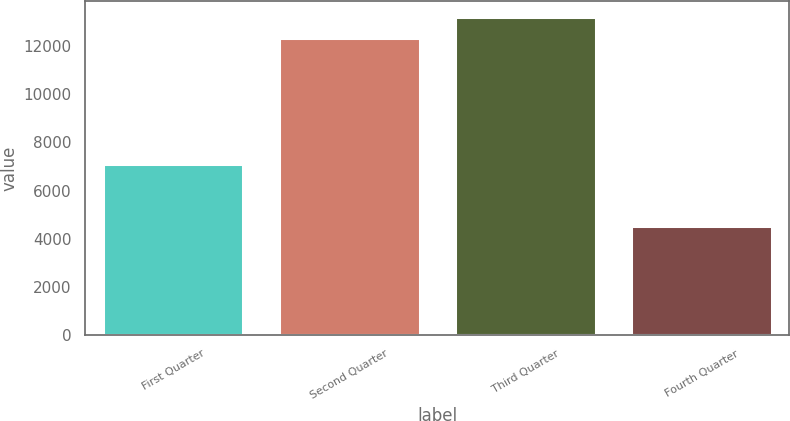Convert chart. <chart><loc_0><loc_0><loc_500><loc_500><bar_chart><fcel>First Quarter<fcel>Second Quarter<fcel>Third Quarter<fcel>Fourth Quarter<nl><fcel>7114<fcel>12319<fcel>13189<fcel>4550<nl></chart> 